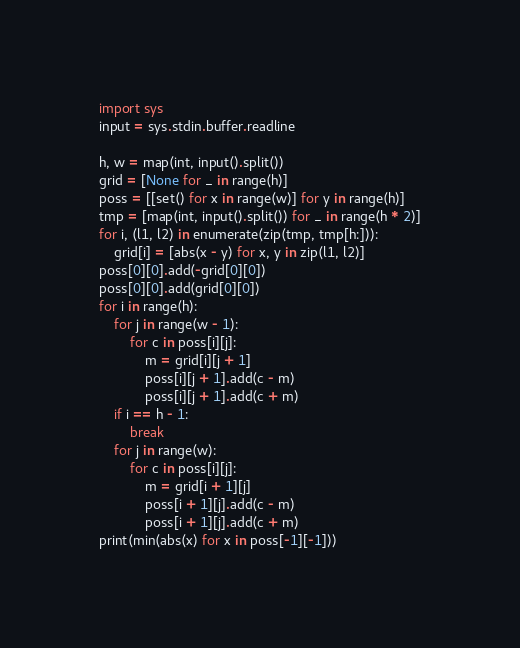<code> <loc_0><loc_0><loc_500><loc_500><_Python_>import sys
input = sys.stdin.buffer.readline

h, w = map(int, input().split())
grid = [None for _ in range(h)]
poss = [[set() for x in range(w)] for y in range(h)]
tmp = [map(int, input().split()) for _ in range(h * 2)]
for i, (l1, l2) in enumerate(zip(tmp, tmp[h:])):
	grid[i] = [abs(x - y) for x, y in zip(l1, l2)]
poss[0][0].add(-grid[0][0])
poss[0][0].add(grid[0][0])
for i in range(h):
	for j in range(w - 1):
		for c in poss[i][j]:
			m = grid[i][j + 1]
			poss[i][j + 1].add(c - m)
			poss[i][j + 1].add(c + m)
	if i == h - 1:
		break
	for j in range(w):
		for c in poss[i][j]:
			m = grid[i + 1][j]
			poss[i + 1][j].add(c - m)
			poss[i + 1][j].add(c + m)
print(min(abs(x) for x in poss[-1][-1]))</code> 